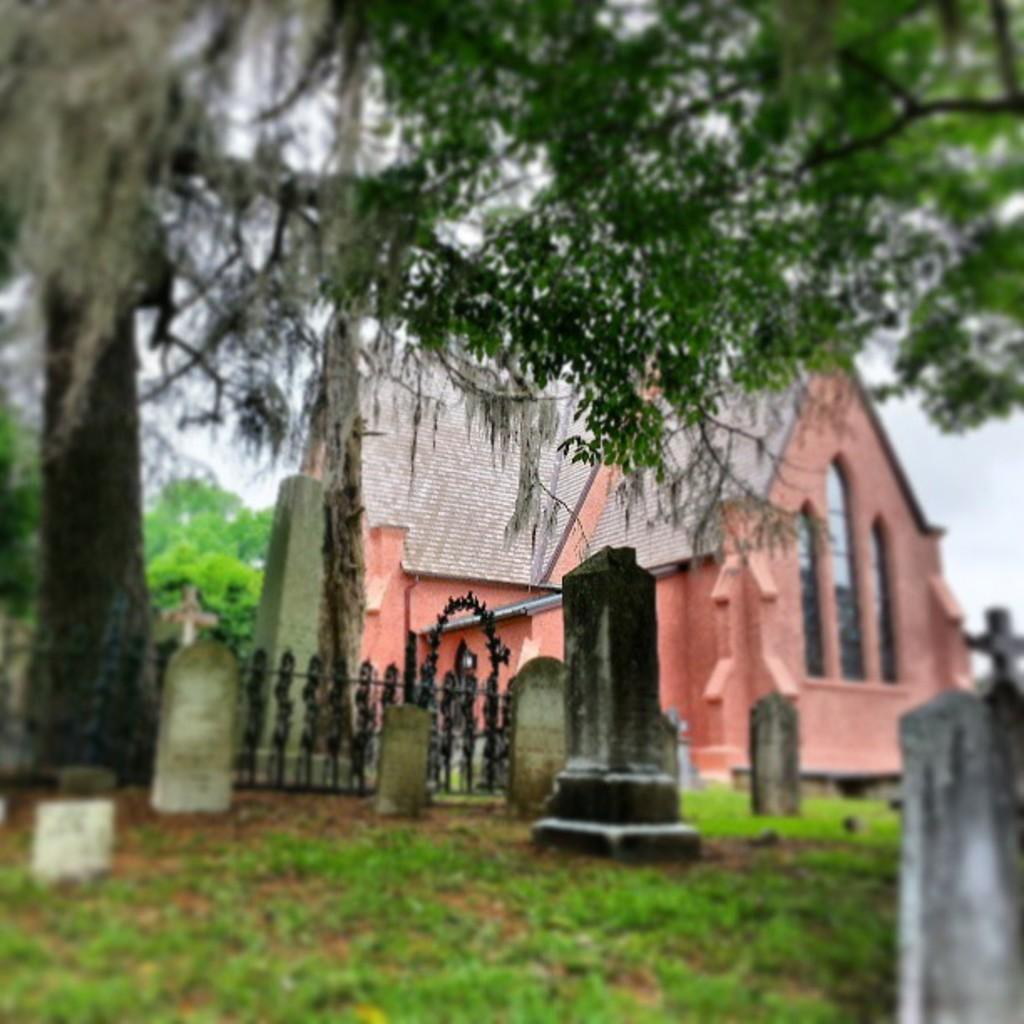What type of structures can be seen in the image? There are gravestones in the image. What other elements are present in the image besides the gravestones? There are trees, fencing, a house, and a clear sky visible in the image. Can you describe the background of the image? The background of the image includes trees, fencing, a house, and a clear sky. What type of fuel is being used by the yoke in the image? There is no yoke or fuel present in the image. 